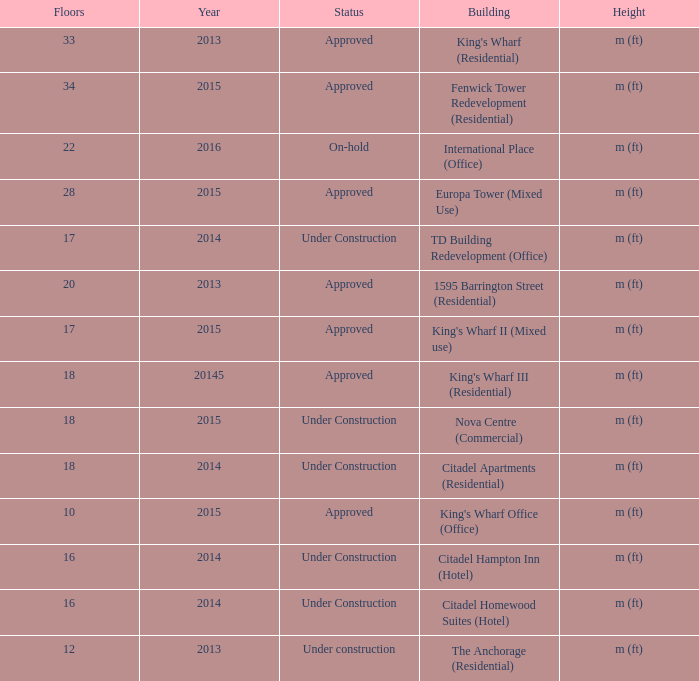What are the number of floors for the building of td building redevelopment (office)? 17.0. 